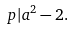<formula> <loc_0><loc_0><loc_500><loc_500>p | a ^ { 2 } - 2 .</formula> 